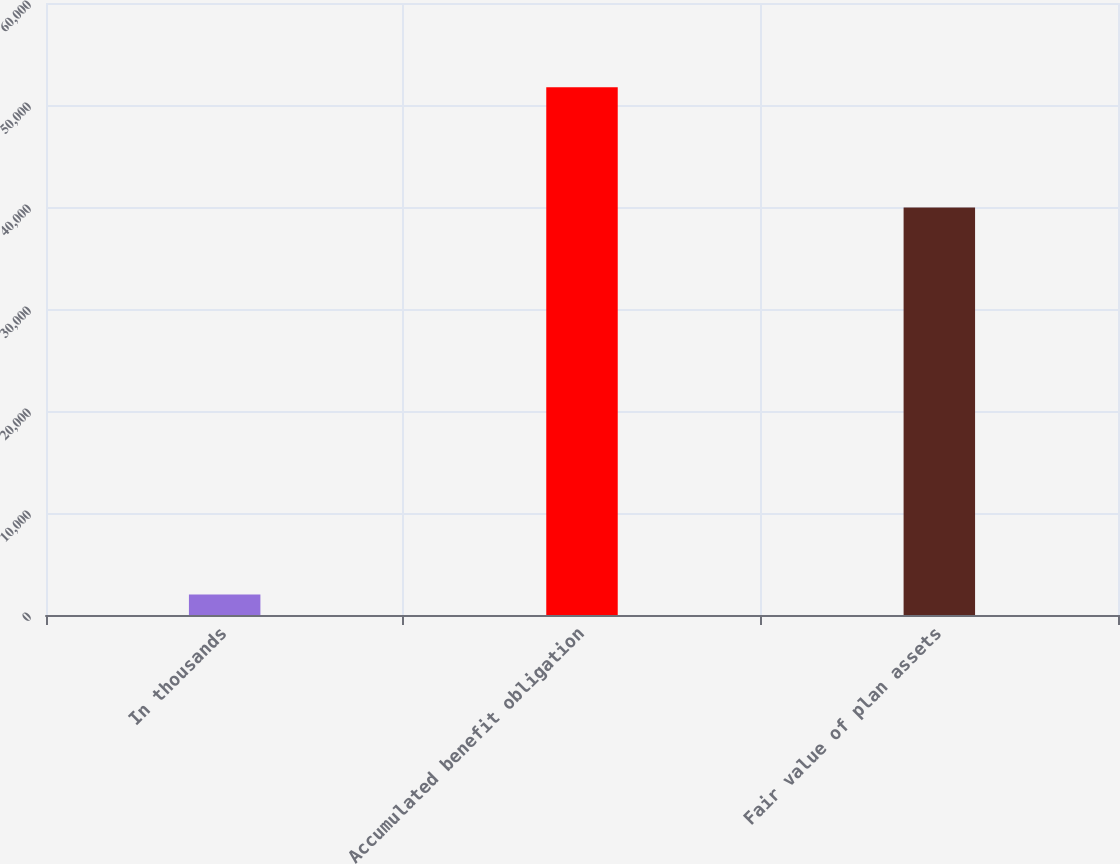Convert chart. <chart><loc_0><loc_0><loc_500><loc_500><bar_chart><fcel>In thousands<fcel>Accumulated benefit obligation<fcel>Fair value of plan assets<nl><fcel>2011<fcel>51735<fcel>39951<nl></chart> 